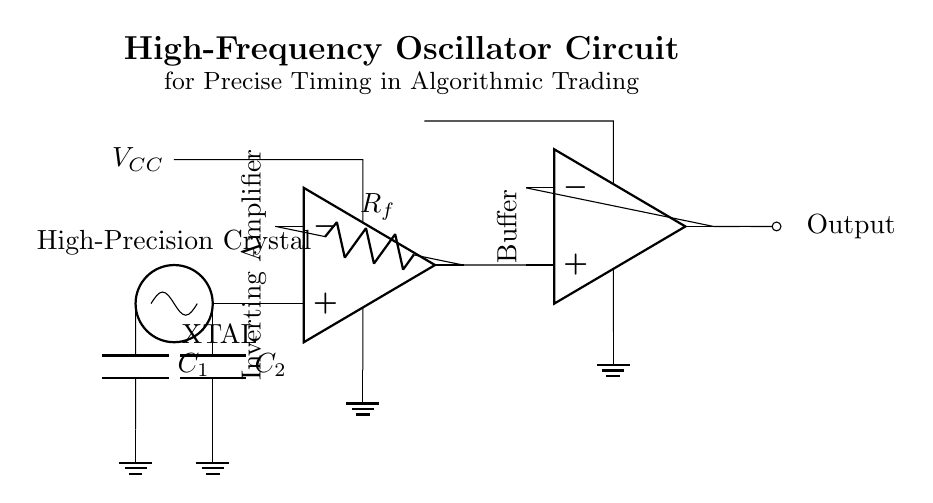What is the type of oscillator used in the circuit? The circuit diagram shows a high-precision crystal oscillator, identified by the labeled component marked as "XTAL."
Answer: Crystal oscillator What are the values of the capacitors in the circuit? The circuit only labels the capacitors generically as "C1" and "C2," without specific values. Therefore, no numeric value can be provided.
Answer: C1 and C2 What component acts as the feedback element in the circuit? The feedback resistor is denoted by "R_f" and is connected to the output of the inverting amplifier, indicating its role in feedback.
Answer: Feedback resistor How many operational amplifiers are in the circuit? Examining the diagram, there are two operational amplifiers indicated, each marked clearly, one for inversion and one for buffering.
Answer: Two What is the function of the buffer in this circuit? The buffer amplifies the signal from the inverting amplifier without loading down the preceding stage, providing a higher current drive capability for the output.
Answer: Signal isolation What are the voltage connections in the circuit? The circuit diagram shows a positive voltage connection labeled as "V_CC" and ground connections for both operational amplifiers, indicating their power supply configuration.
Answer: V_CC and ground What is the primary application of the circuit? The circuit is specifically designed for precise timing in the context of algorithmic trading, as stated in the title of the diagram.
Answer: Algorithmic trading 